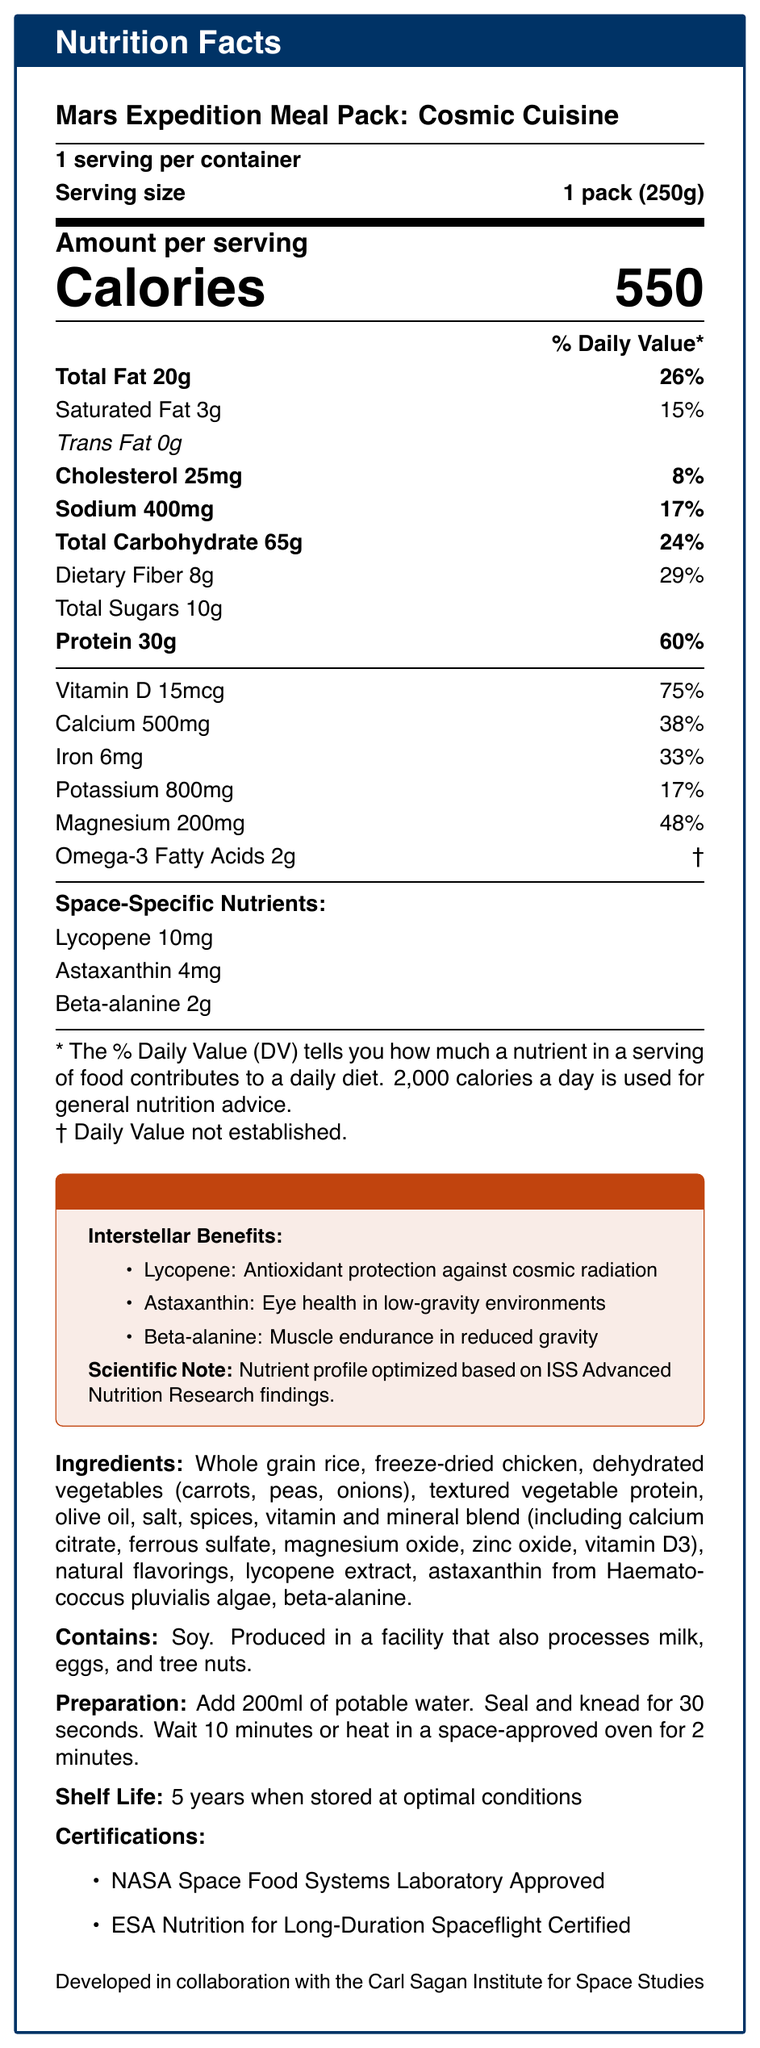what is the serving size for the Mars Expedition Meal Pack? The serving size is clearly listed as "1 pack (250g)" in the nutrition facts.
Answer: 1 pack (250g) how many calories are there per serving? The amount of calories per serving is shown as 550.
Answer: 550 what percentage of the daily value for Vitamin D does this meal provide? The document shows that Vitamin D provides 75% of the Daily Value.
Answer: 75% which nutrient has the highest percentage of Daily Value per serving? According to the document, Protein offers the highest Daily Value percentage at 60%.
Answer: Protein (60%) what is the function of Beta-alanine listed under the space-specific nutrients? Beta-alanine's benefit is noted as "Muscle endurance in reduced gravity."
Answer: Muscle endurance in reduced gravity which nutrient provides 29% of the Daily Value per serving? A. Calcium B. Dietary Fiber C. Potassium D. Iron The document indicates that Dietary Fiber provides 29% of the Daily Value per serving.
Answer: B. Dietary Fiber how many milligrams of Calcium are there per serving? The document lists the amount of Calcium as 500 mg per serving.
Answer: 500 mg are there any allergens mentioned for this meal pack? The allergen information states that the product contains soy and is produced in a facility that processes milk, eggs, and tree nuts.
Answer: Yes what specific benefit does Lycopene provide for space missions? A. Muscle endurance B. Eye health C. Bone density maintenance D. Antioxidant protection Lycopene is specifically noted for "Antioxidant protection against cosmic radiation."
Answer: D. Antioxidant protection does the meal pack contain Omega-3 Fatty Acids? The document lists Omega-3 Fatty Acids as one of the nutrients (2g).
Answer: Yes what is the product name? The product name is prominently displayed as "Mars Expedition Meal Pack: Cosmic Cuisine."
Answer: Mars Expedition Meal Pack: Cosmic Cuisine what are the preparation instructions for this meal pack? Preparation instructions are explicitly stated in the document.
Answer: Add 200ml of potable water. Seal and knead for 30 seconds. Wait 10 minutes or heat in a space-approved oven for 2 minutes. how long can this meal pack be stored under optimal conditions? The shelf life is mentioned as 5 years when stored at optimal conditions.
Answer: 5 years is the amount of Trans Fat in this meal significant? The document shows that the amount of Trans Fat is 0g.
Answer: No summarize the main features and benefits of this meal pack. The summary encapsulates the major aspects of the meal pack, highlighting its nutrient profile, space-specific benefits, storage, and preparation.
Answer: This meal pack, called "Mars Expedition Meal Pack: Cosmic Cuisine," is designed for space missions, offering a serving size of 250g with 550 calories. It includes essential nutrients like Protein, Vitamin D, Calcium, Iron, and specialized space-specific nutrients such as Lycopene, Astaxanthin, and Beta-alanine for antioxidant protection, eye health, and muscle endurance. The product has a 5-year shelf life and is approved by NASA and ESA. Ingredients include whole grain rice, freeze-dried chicken, dehydrated vegetables, and a vitamin and mineral blend. The pack is prepared easily by adding water and kneading. who developed this meal pack? The document mentions that it was developed in collaboration with the Carl Sagan Institute for Space Studies.
Answer: The Carl Sagan Institute for Space Studies what percentage of Daily Value for Potassium does this meal pack provide? The Daily Value percentage for Potassium is listed as 17%.
Answer: 17% can we find the exact production location of the meal pack in the document? The document does not provide information about the exact production location.
Answer: Cannot be determined how many servings are there in one container of this meal pack? The document clearly states that there is 1 serving per container.
Answer: 1 